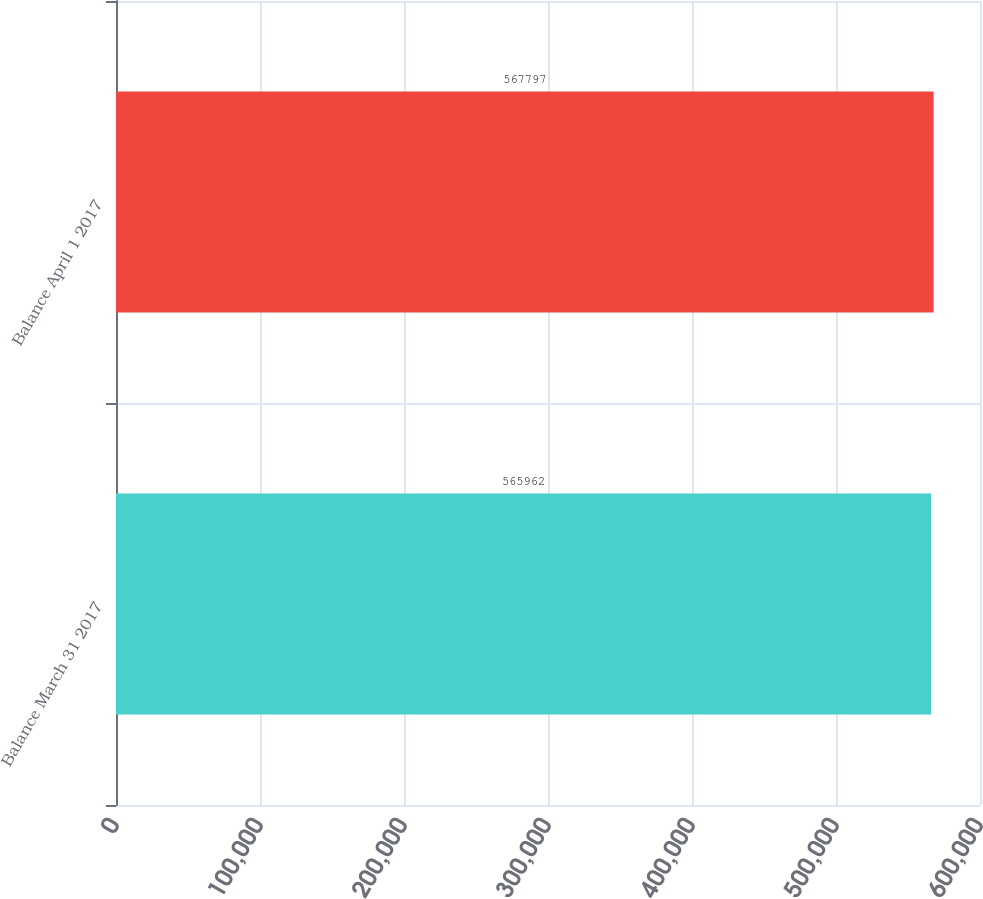Convert chart. <chart><loc_0><loc_0><loc_500><loc_500><bar_chart><fcel>Balance March 31 2017<fcel>Balance April 1 2017<nl><fcel>565962<fcel>567797<nl></chart> 